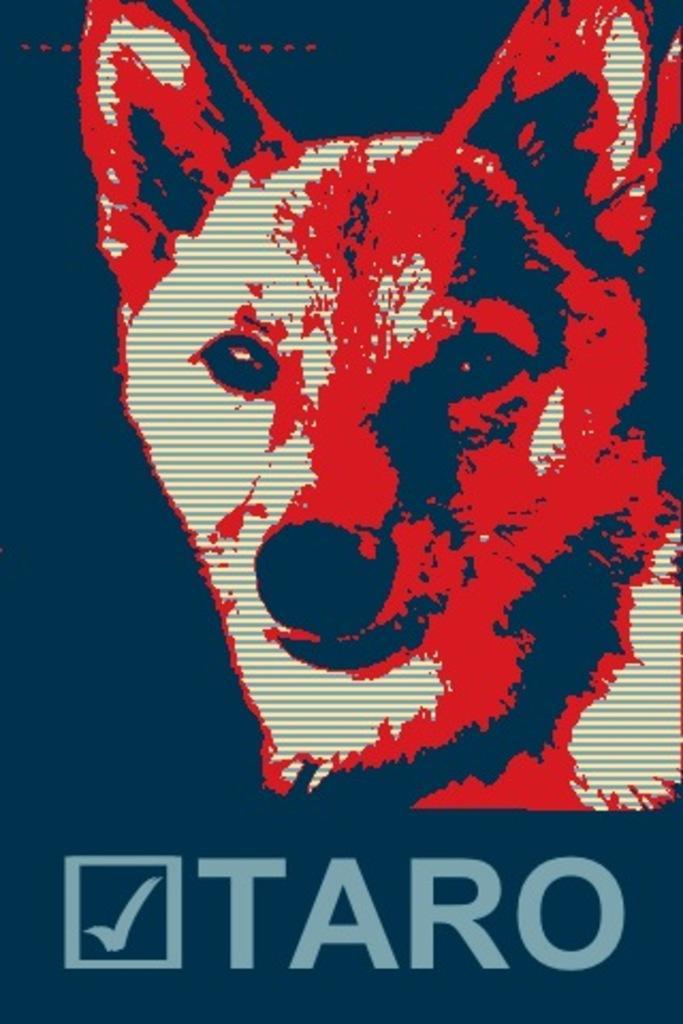Describe this image in one or two sentences. This is a dog. 